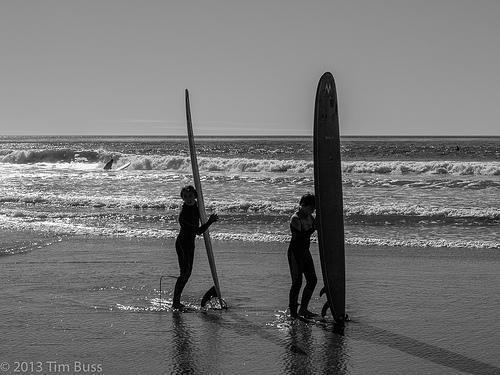How many people are in the picture?
Give a very brief answer. 2. 